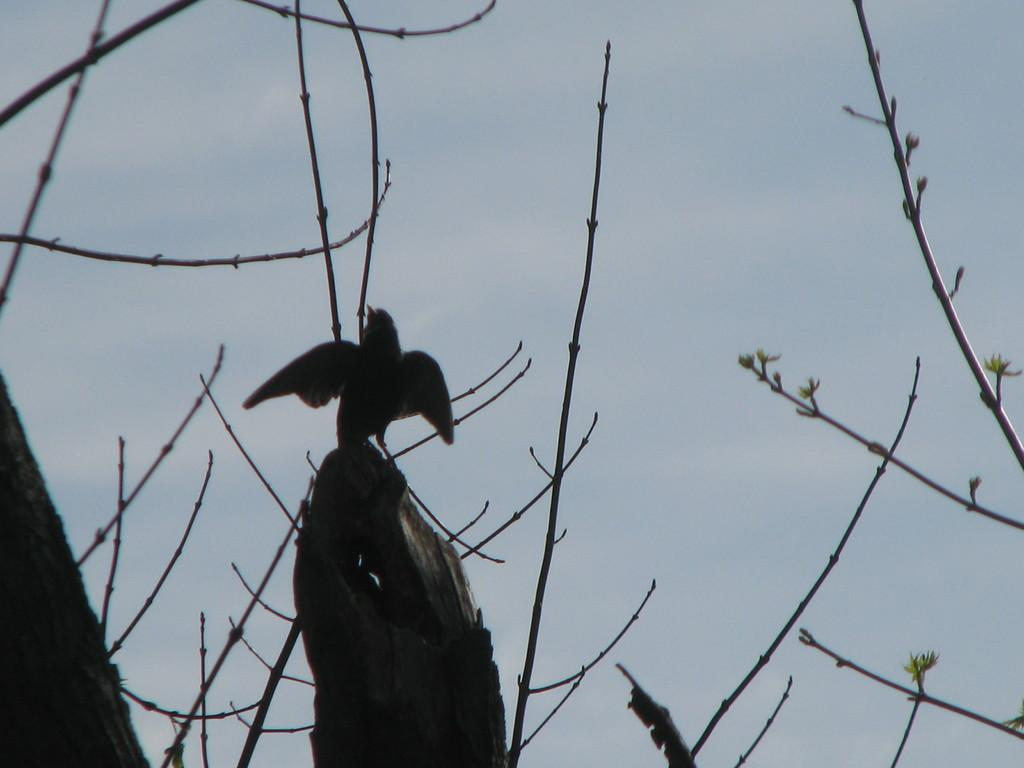Where was the image taken? The image was taken outdoors. What can be seen in the background of the image? There is a sky with clouds in the background. What type of vegetation is present in the image? There are dry plants in the image. What animal can be seen in the image? There is a bird on the bark in the middle of the image. How many eggs can be seen in the image? There are no eggs present in the image. What type of light source is illuminating the image? The facts provided do not mention a light source, so we cannot determine the type of light illuminating the image. 